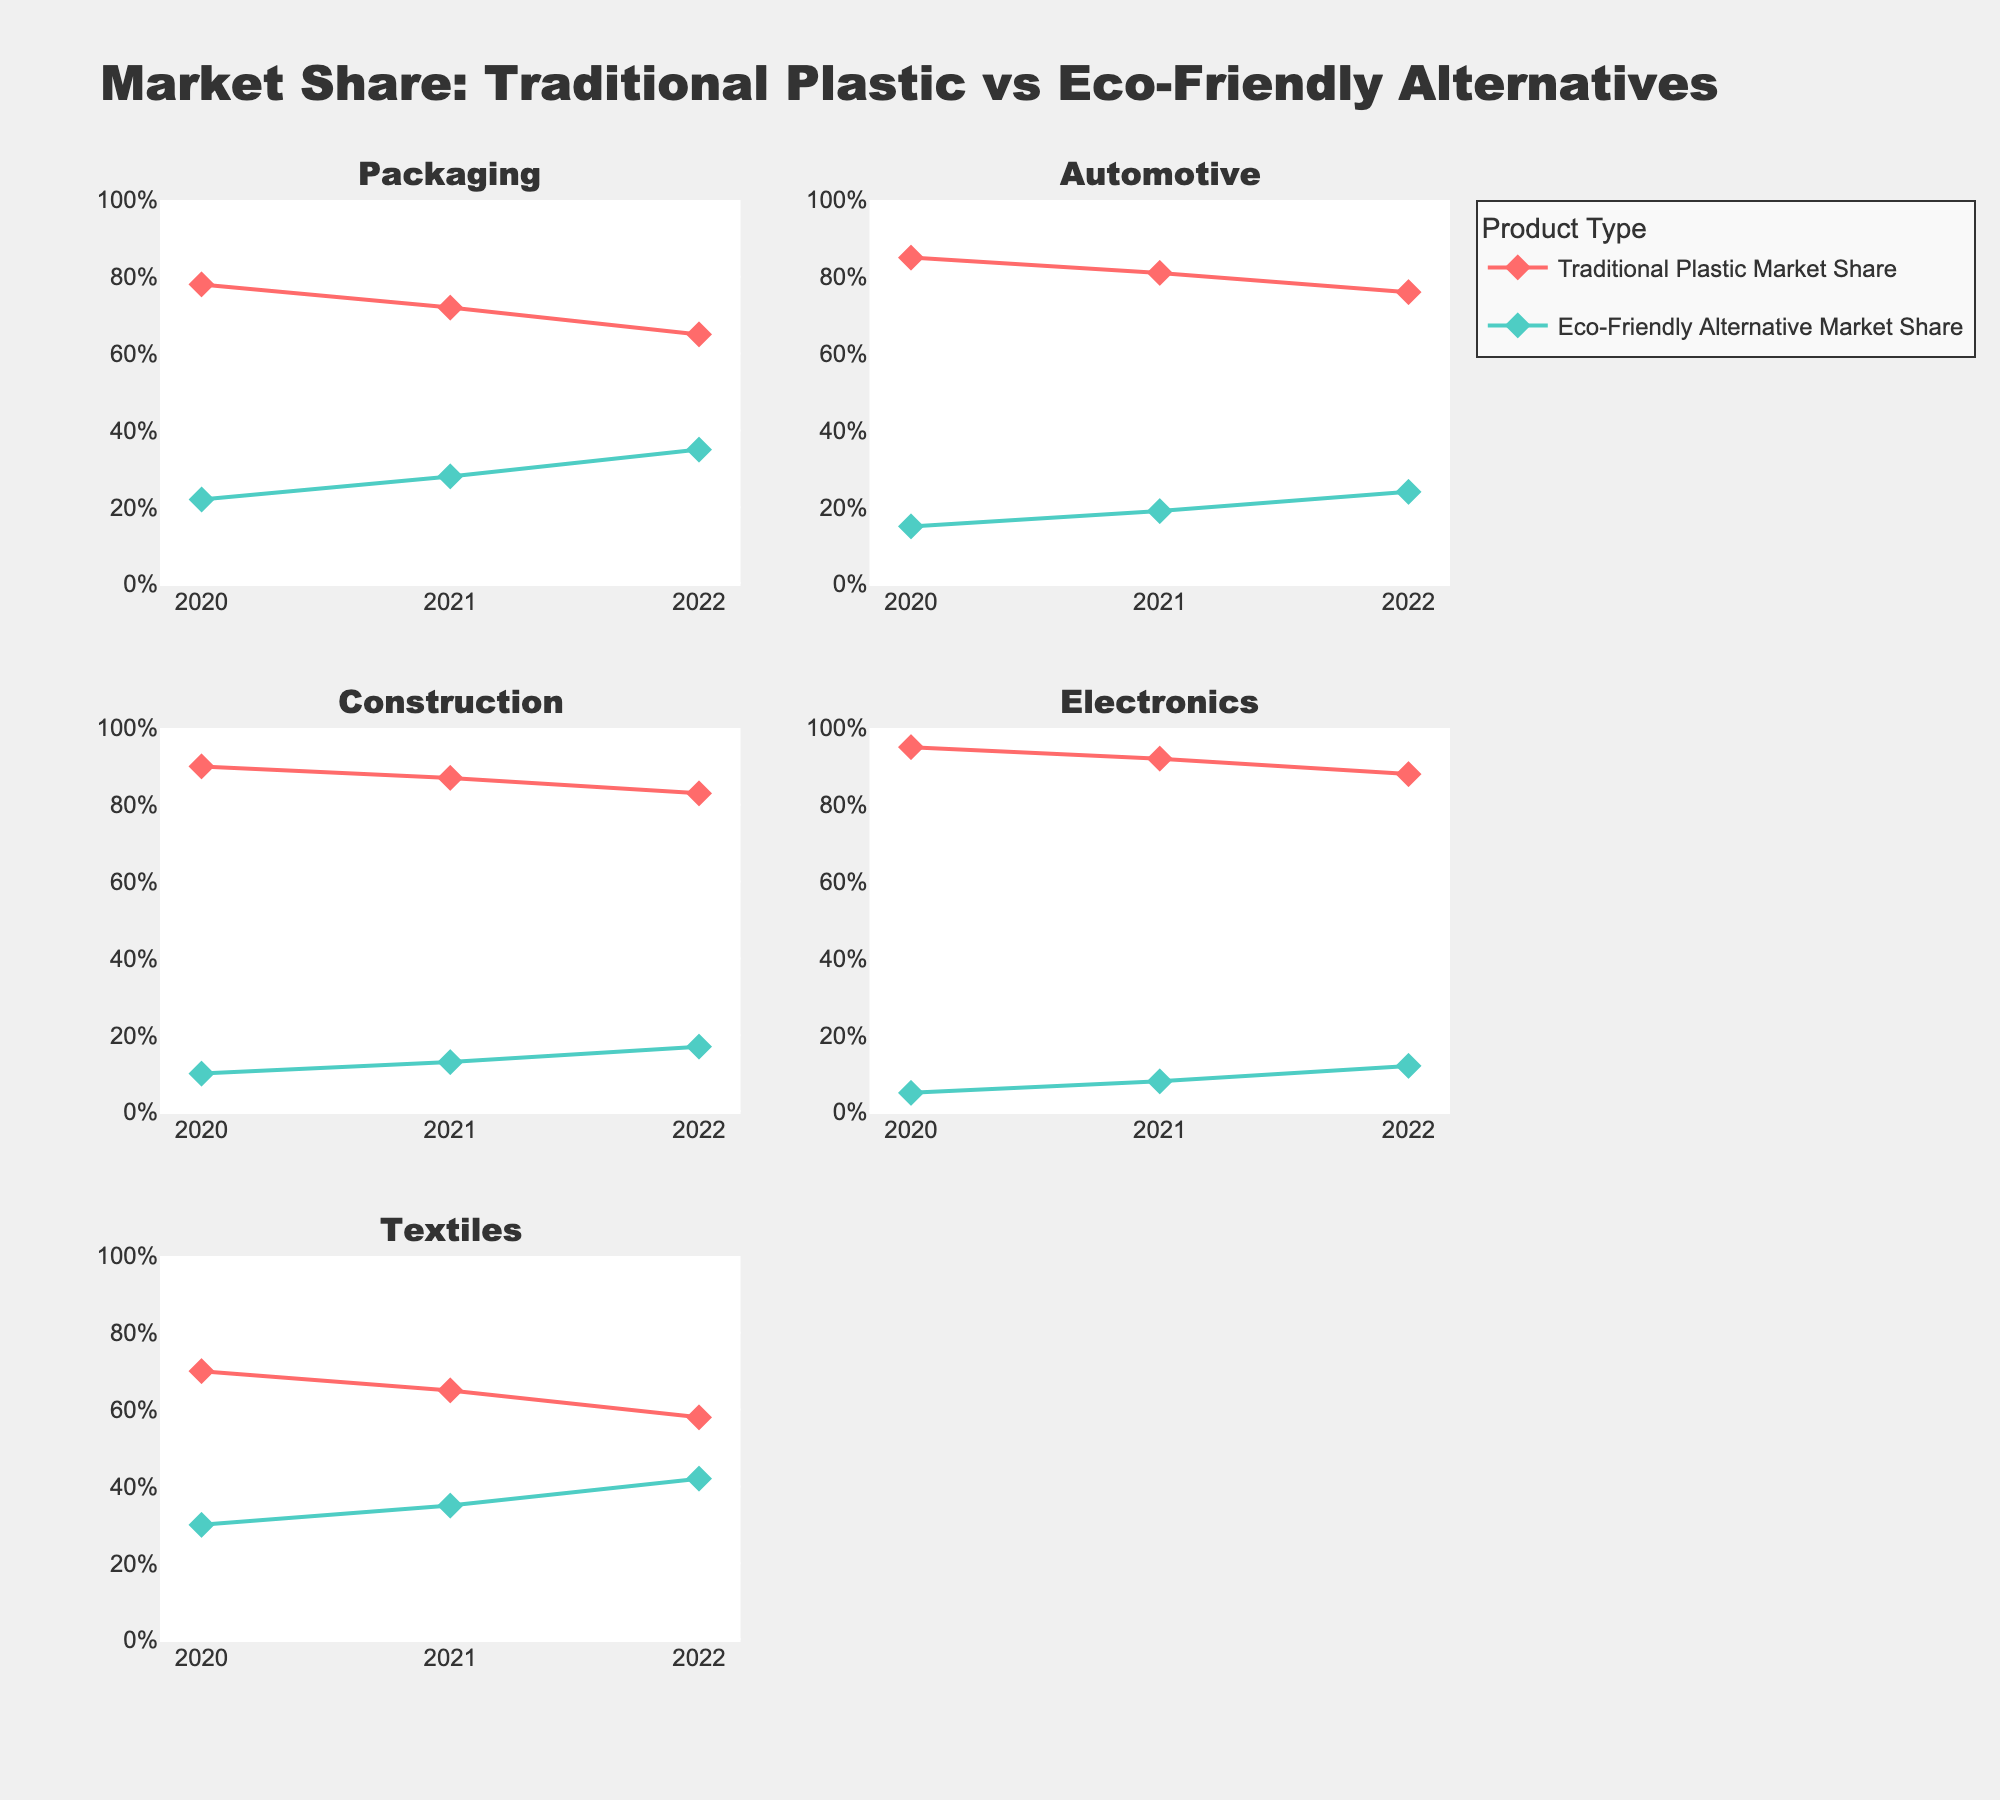What is the title of the figure? The title is typically located at the top of the figure and directly states what the plot is about. In this case, the title says "Market Share: Traditional Plastic vs Eco-Friendly Alternatives".
Answer: Market Share: Traditional Plastic vs Eco-Friendly Alternatives How many subplots are there in the figure? The figure layout indicates there are different industries shown. Counting the subplot titles, we find there are 5 industries. Each industry appears as a separate subplot panel.
Answer: 5 In which industry did the Market Share of Eco-Friendly Alternatives increase the most from 2020 to 2022? To determine this, for each industry, calculate the difference between the Eco-Friendly Alternative Market Share in 2022 and 2020. The increases in Packaging, Automotive, Construction, Electronics, and Textiles are 13%, 9%, 7%, 7%, and 12% respectively. The largest increase is in Packaging at 13%.
Answer: Packaging What is the trend of Traditional Plastic Market Share in the Electronics industry? Observe the plot segment for Electronics: in 2020, the share is 95%, in 2021 it reduces to 92%, and in 2022 it reduces further to 88%. This consistent decrease shows a downward trend.
Answer: Downward trend Comparing the Market Shares of the Construction and Automotive industries in 2022, which has a higher eco-friendly market share? Look at the scatter plot points for 2022: Construction shows 17% and Automotive shows 24%. 24% is higher than 17%.
Answer: Automotive What is the average Market Share of Traditional Plastics for the Packaging industry over the period 2020-2022? To find the average: (78% + 72% + 65%) / 3 = 215 / 3 = 71.67%. The average is computed by summing up the percentages and dividing by the number of data points.
Answer: 71.67% Did the Traditional Plastic Market Share in Textiles drop below 60% at any point in the period 2020-2022? Look at the Textiles subplot: the values in 2020, 2021, and 2022 are 70%, 65%, and 58% respectively. In 2022, the share is 58% which is below 60%.
Answer: Yes Which industry's Traditional Plastic Market Share is the highest in 2021? Identify the highest value for 2021 in the subplots. Values for 2021 for all industries are: Packaging (72%), Automotive (81%), Construction (87%), Electronics (92%), Textiles (65%). Electronics, with 92%, is the highest.
Answer: Electronics 